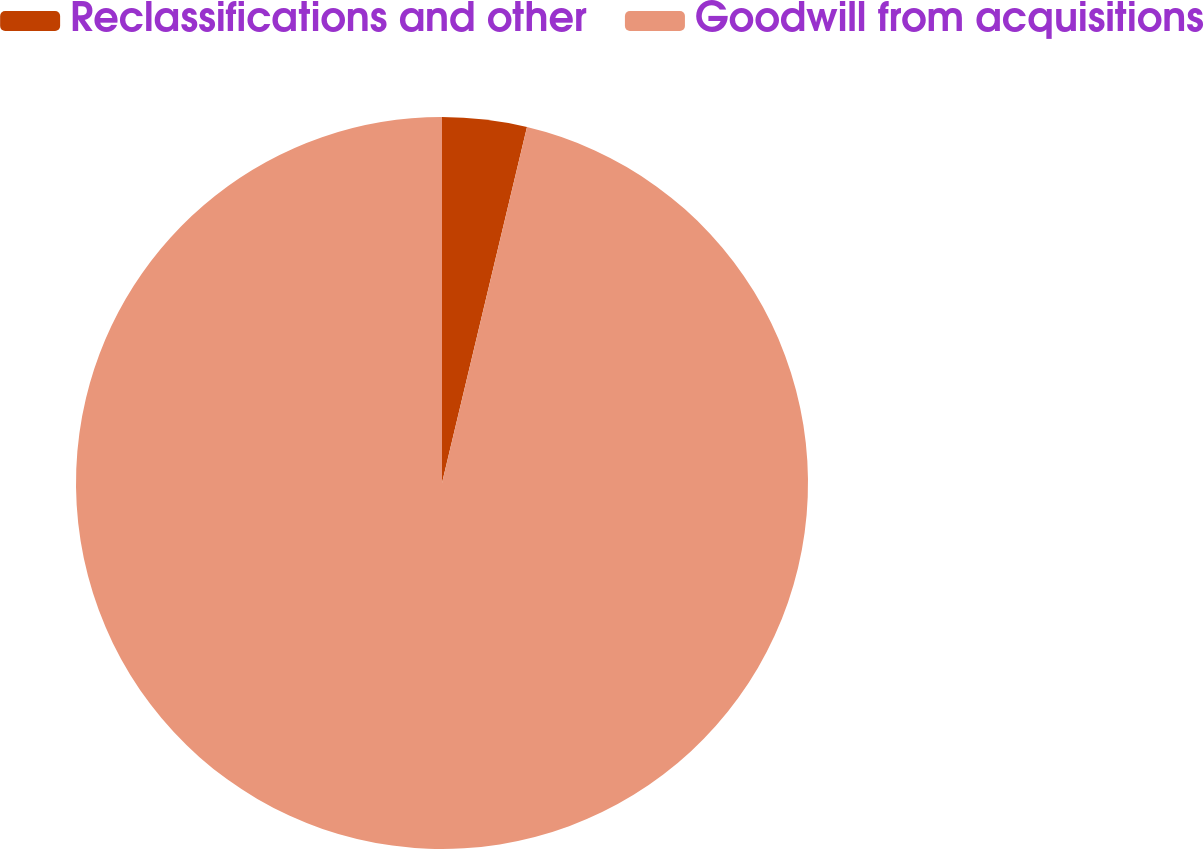Convert chart to OTSL. <chart><loc_0><loc_0><loc_500><loc_500><pie_chart><fcel>Reclassifications and other<fcel>Goodwill from acquisitions<nl><fcel>3.73%<fcel>96.27%<nl></chart> 